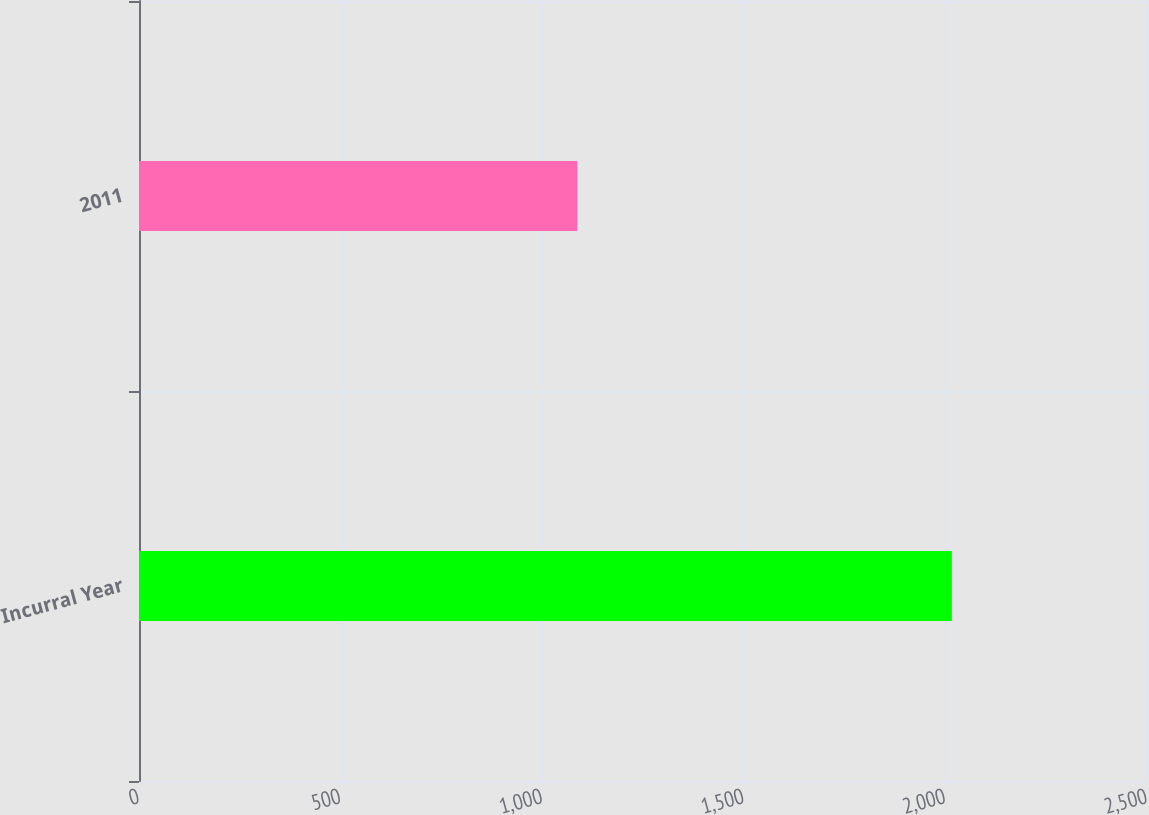Convert chart. <chart><loc_0><loc_0><loc_500><loc_500><bar_chart><fcel>Incurral Year<fcel>2011<nl><fcel>2016<fcel>1087<nl></chart> 